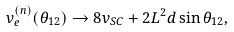Convert formula to latex. <formula><loc_0><loc_0><loc_500><loc_500>v _ { e } ^ { ( n ) } ( \theta _ { 1 2 } ) \rightarrow 8 v _ { S C } + 2 L ^ { 2 } d \sin \theta _ { 1 2 } ,</formula> 